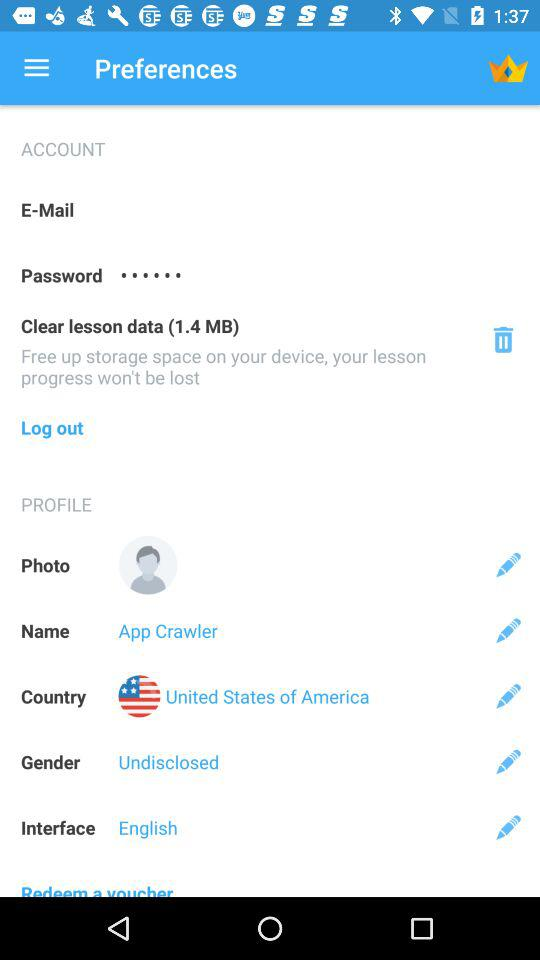How much storage space for the lesson data?
When the provided information is insufficient, respond with <no answer>. <no answer> 